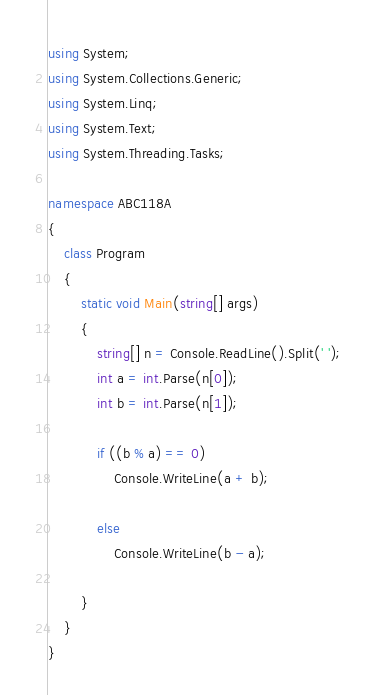Convert code to text. <code><loc_0><loc_0><loc_500><loc_500><_C#_>using System;
using System.Collections.Generic;
using System.Linq;
using System.Text;
using System.Threading.Tasks;

namespace ABC118A
{
	class Program
	{
		static void Main(string[] args)
		{
			string[] n = Console.ReadLine().Split(' ');
			int a = int.Parse(n[0]);
			int b = int.Parse(n[1]);

			if ((b % a) == 0)
				Console.WriteLine(a + b);

			else
				Console.WriteLine(b - a);

		}
	}
}
</code> 